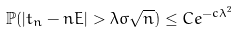<formula> <loc_0><loc_0><loc_500><loc_500>\mathbb { P } ( | t _ { n } - n E | > \lambda \sigma \sqrt { n } ) \leq C e ^ { - c \lambda ^ { 2 } }</formula> 